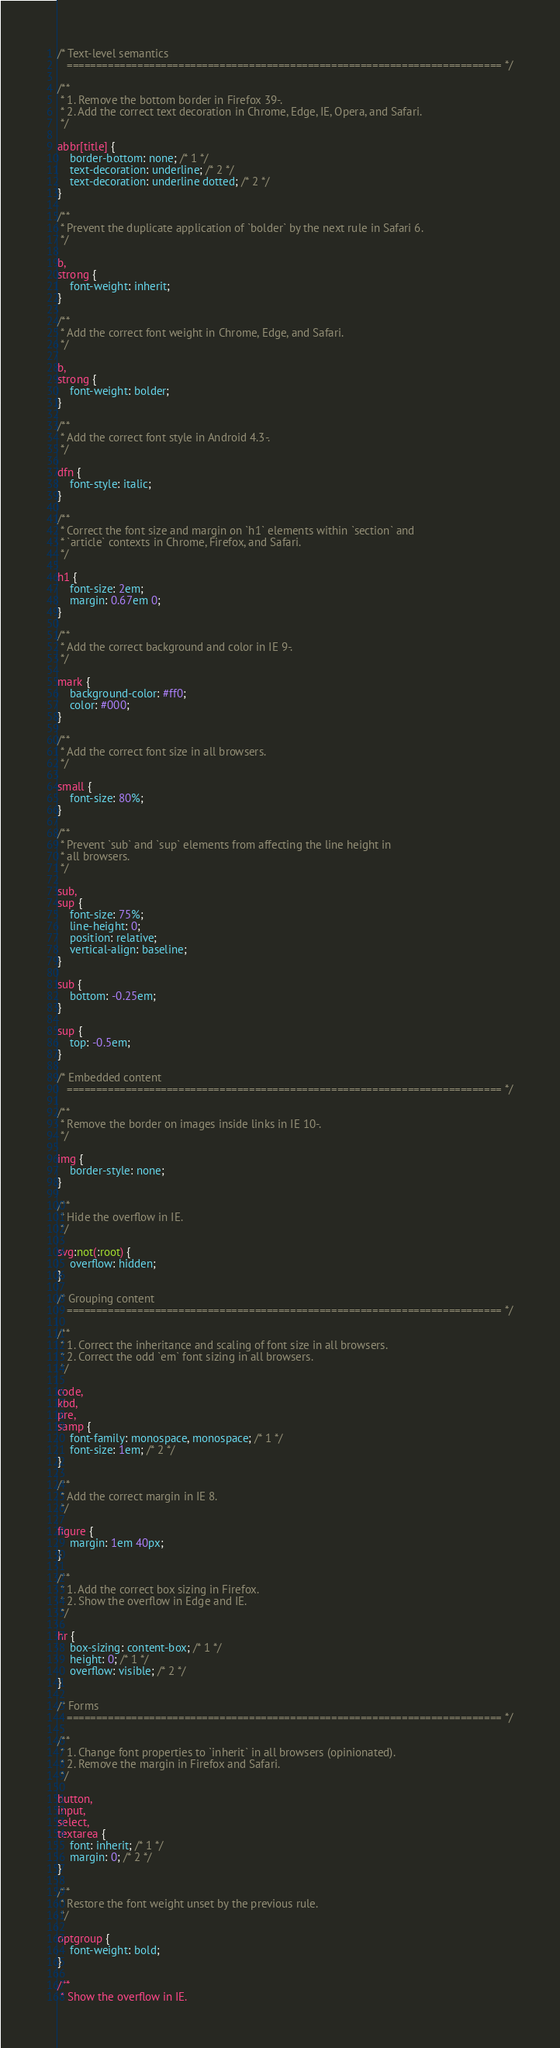<code> <loc_0><loc_0><loc_500><loc_500><_CSS_>/* Text-level semantics
   ========================================================================== */

/**
 * 1. Remove the bottom border in Firefox 39-.
 * 2. Add the correct text decoration in Chrome, Edge, IE, Opera, and Safari.
 */

abbr[title] {
    border-bottom: none; /* 1 */
    text-decoration: underline; /* 2 */
    text-decoration: underline dotted; /* 2 */
}

/**
 * Prevent the duplicate application of `bolder` by the next rule in Safari 6.
 */

b,
strong {
    font-weight: inherit;
}

/**
 * Add the correct font weight in Chrome, Edge, and Safari.
 */

b,
strong {
    font-weight: bolder;
}

/**
 * Add the correct font style in Android 4.3-.
 */

dfn {
    font-style: italic;
}

/**
 * Correct the font size and margin on `h1` elements within `section` and
 * `article` contexts in Chrome, Firefox, and Safari.
 */

h1 {
    font-size: 2em;
    margin: 0.67em 0;
}

/**
 * Add the correct background and color in IE 9-.
 */

mark {
    background-color: #ff0;
    color: #000;
}

/**
 * Add the correct font size in all browsers.
 */

small {
    font-size: 80%;
}

/**
 * Prevent `sub` and `sup` elements from affecting the line height in
 * all browsers.
 */

sub,
sup {
    font-size: 75%;
    line-height: 0;
    position: relative;
    vertical-align: baseline;
}

sub {
    bottom: -0.25em;
}

sup {
    top: -0.5em;
}

/* Embedded content
   ========================================================================== */

/**
 * Remove the border on images inside links in IE 10-.
 */

img {
    border-style: none;
}

/**
 * Hide the overflow in IE.
 */

svg:not(:root) {
    overflow: hidden;
}

/* Grouping content
   ========================================================================== */

/**
 * 1. Correct the inheritance and scaling of font size in all browsers.
 * 2. Correct the odd `em` font sizing in all browsers.
 */

code,
kbd,
pre,
samp {
    font-family: monospace, monospace; /* 1 */
    font-size: 1em; /* 2 */
}

/**
 * Add the correct margin in IE 8.
 */

figure {
    margin: 1em 40px;
}

/**
 * 1. Add the correct box sizing in Firefox.
 * 2. Show the overflow in Edge and IE.
 */

hr {
    box-sizing: content-box; /* 1 */
    height: 0; /* 1 */
    overflow: visible; /* 2 */
}

/* Forms
   ========================================================================== */

/**
 * 1. Change font properties to `inherit` in all browsers (opinionated).
 * 2. Remove the margin in Firefox and Safari.
 */

button,
input,
select,
textarea {
    font: inherit; /* 1 */
    margin: 0; /* 2 */
}

/**
 * Restore the font weight unset by the previous rule.
 */

optgroup {
    font-weight: bold;
}

/**
 * Show the overflow in IE.</code> 